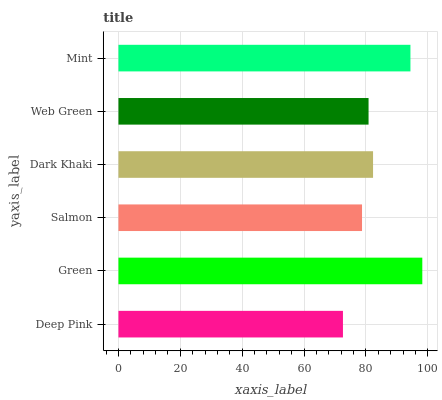Is Deep Pink the minimum?
Answer yes or no. Yes. Is Green the maximum?
Answer yes or no. Yes. Is Salmon the minimum?
Answer yes or no. No. Is Salmon the maximum?
Answer yes or no. No. Is Green greater than Salmon?
Answer yes or no. Yes. Is Salmon less than Green?
Answer yes or no. Yes. Is Salmon greater than Green?
Answer yes or no. No. Is Green less than Salmon?
Answer yes or no. No. Is Dark Khaki the high median?
Answer yes or no. Yes. Is Web Green the low median?
Answer yes or no. Yes. Is Mint the high median?
Answer yes or no. No. Is Green the low median?
Answer yes or no. No. 